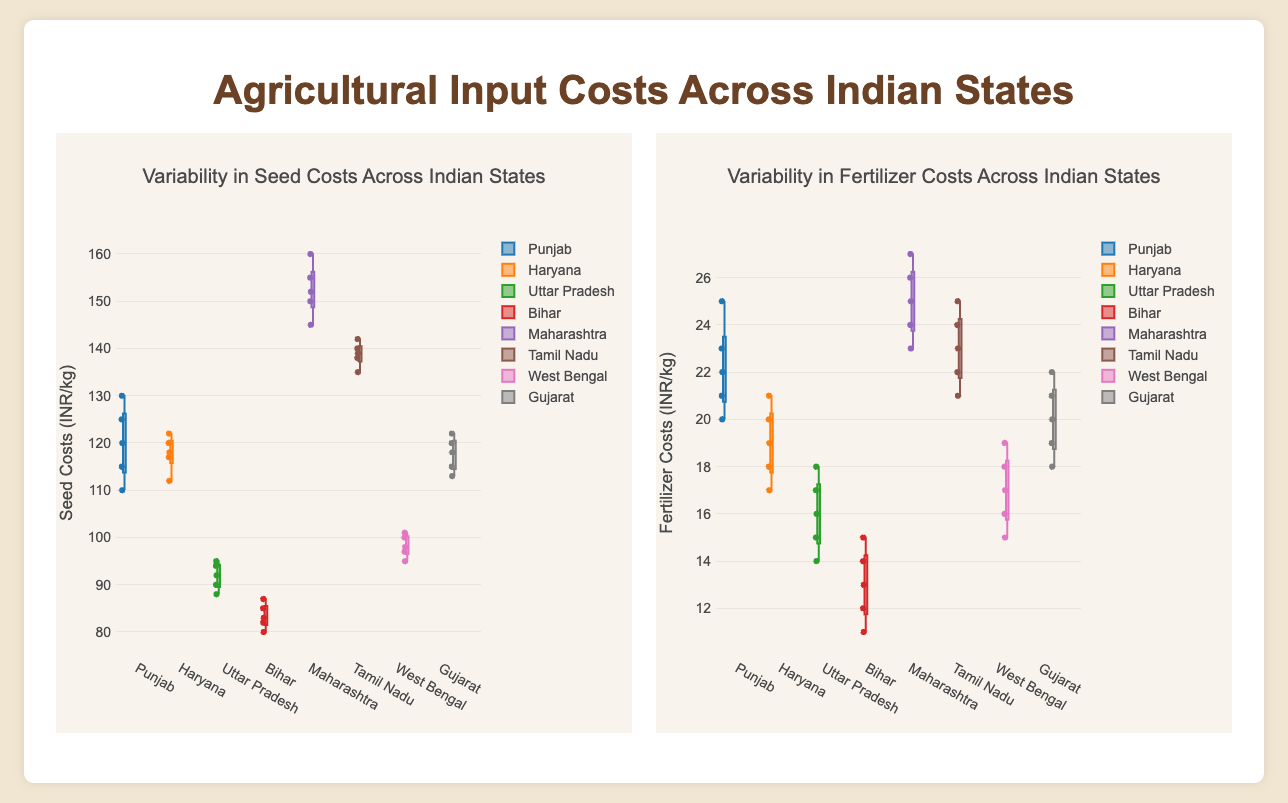What is the title of the plot showing seed costs variability? The title is located at the top of the plot, which states what is being visualized.
Answer: Variability in Seed Costs Across Indian States Which state has the highest median seed cost? The box plot’s horizontal line inside the box represents the median. The state with the highest position of this line has the highest median.
Answer: Maharashtra How many data points are used to show the seed costs for Haryana? Each box plot includes small dots that represent individual data points. Count these points for Haryana.
Answer: 5 What is the range of fertilizer costs in Bihar? The range can be determined by looking at the ends of the whiskers (lines extending from the box) for Bihar's fertilizer cost plot.
Answer: 11 to 15 INR/kg Which state has the lowest minimum fertilizer cost? The minimum value is marked by the bottom whisker of the box plot. Identify the state with the lowest position whisker.
Answer: Bihar How does the average seed cost in Gujarat compare to that in West Bengal? Find the mean (average) from the distribution of points or visually compare the central tendency of the points (median or mean indication) between the two states.
Answer: Gujarat's average seed cost is higher than West Bengal's Which state shows the most variability in seed costs, based on the box plot? Look for the state whose box plot has the longest whiskers and widest box, indicating more variability.
Answer: Maharashtra Between the fertilizer costs in Punjab and Tamil Nadu, which state has a higher upper quartile? The upper quartile is the top boundary of the box in a box plot. Compare this boundary for Punjab and Tamil Nadu.
Answer: Tamil Nadu Is the interquartile range (IQR) of seed costs greater in Tamil Nadu or Uttar Pradesh? The IQR is the range between the upper and lower quartiles (ends of the box). Compare the lengths of these boxes for both states.
Answer: Tamil Nadu Which state has the lowest third quartile for seed costs? The third quartile is the top of the box. Identify the state with the lowest top boundary of the box.
Answer: Bihar 